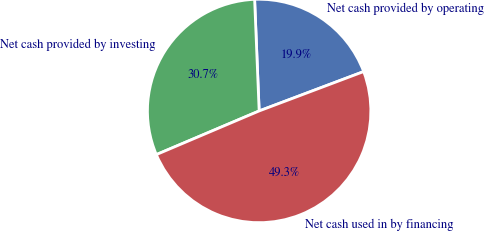<chart> <loc_0><loc_0><loc_500><loc_500><pie_chart><fcel>Net cash provided by operating<fcel>Net cash provided by investing<fcel>Net cash used in by financing<nl><fcel>19.91%<fcel>30.74%<fcel>49.34%<nl></chart> 